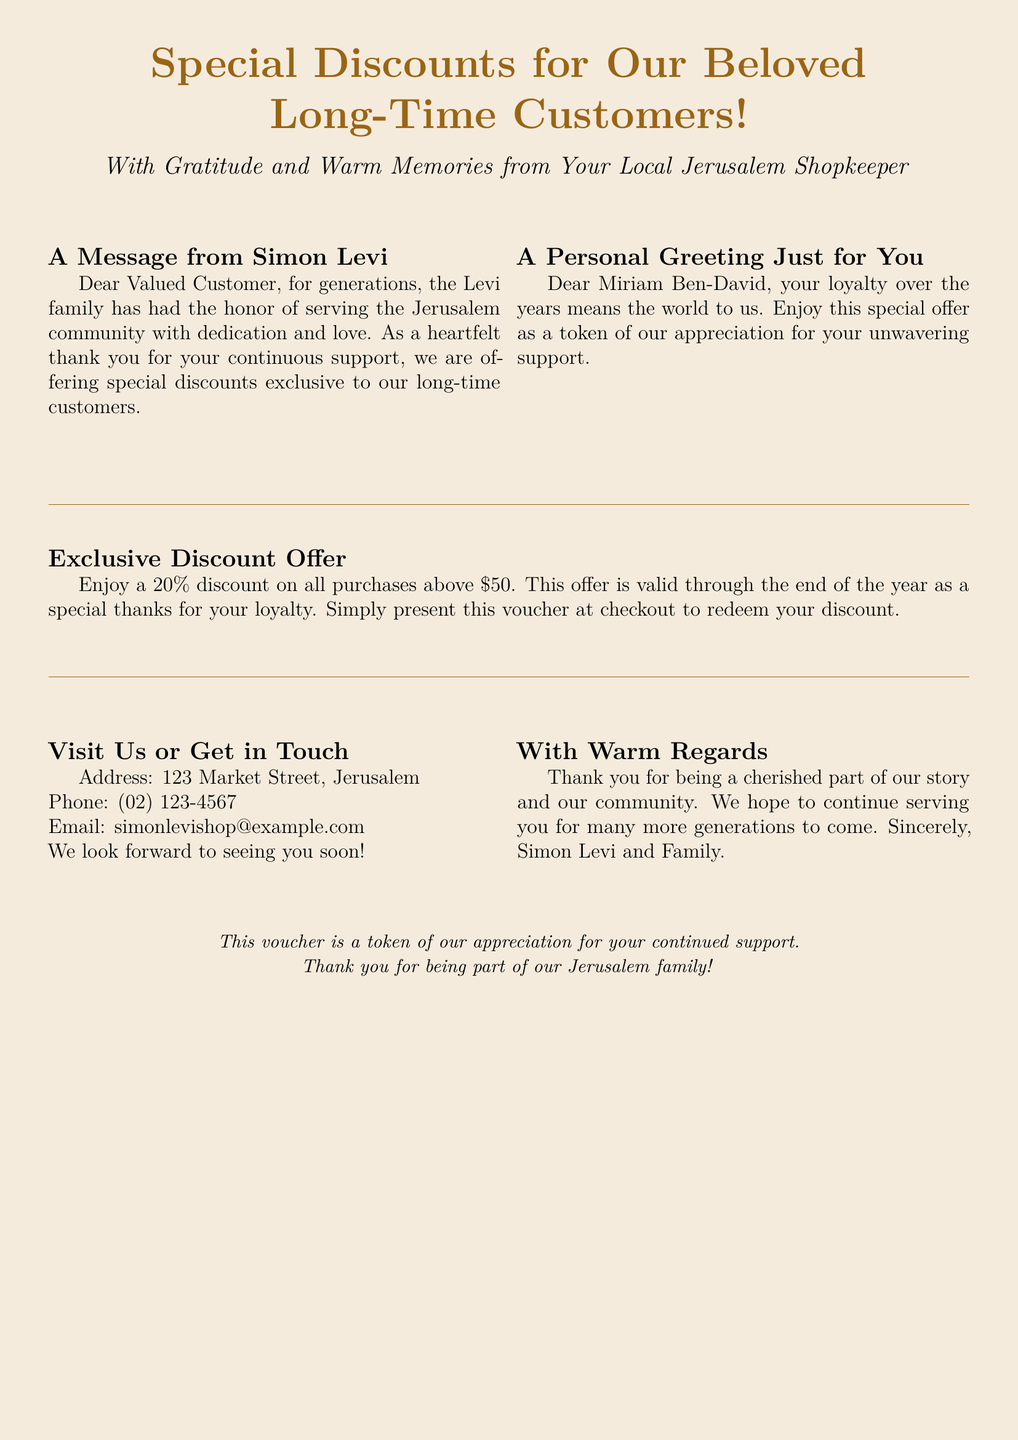What is the discount percentage offered? The document states that customers can enjoy a 20% discount on purchases above $50.
Answer: 20% Who is the message in the voucher addressed to? The document includes a personal greeting specifically to Miriam Ben-David.
Answer: Miriam Ben-David What is the minimum purchase amount to redeem the discount? The document specifies that the discount is applicable for purchases above $50.
Answer: $50 Who signed the voucher? The closing of the document indicates that it is signed by Simon Levi and Family.
Answer: Simon Levi and Family What is the validity period of the discount offer? The document notes that the offer is valid through the end of the year.
Answer: End of the year Where is the shop located? The document includes the address of the shop at 123 Market Street, Jerusalem.
Answer: 123 Market Street, Jerusalem What type of discounts are offered? The document mentions special discounts exclusive to long-time customers as a thank you for their loyalty.
Answer: Special discounts for long-time customers What contact method is provided in the voucher? The document lists a phone number as a way to get in touch.
Answer: (02) 123-4567 